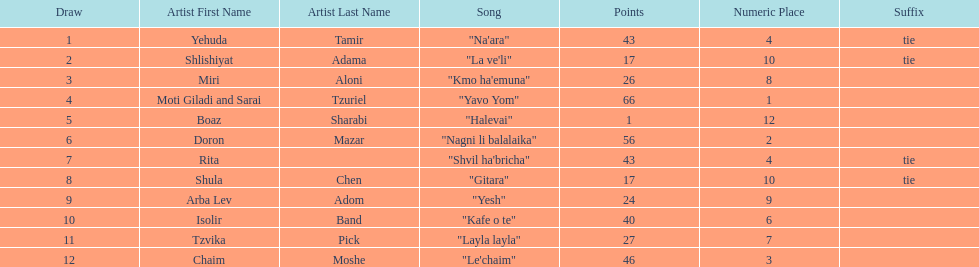Compare draws, which had the least amount of points? Boaz Sharabi. 